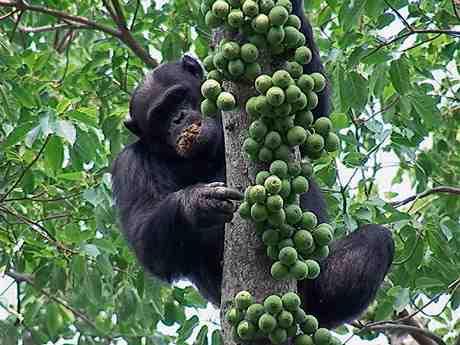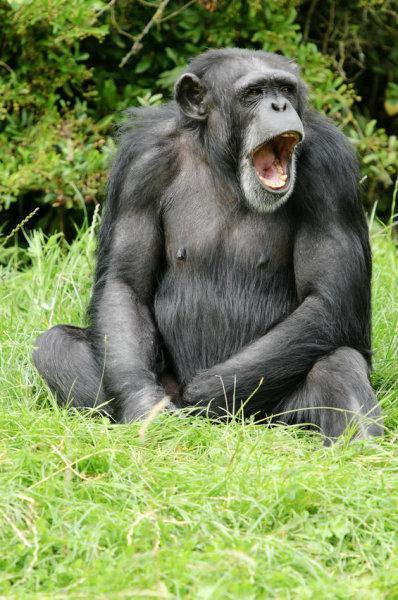The first image is the image on the left, the second image is the image on the right. Evaluate the accuracy of this statement regarding the images: "At least one chimp is squatting on a somewhat horizontal branch, surrounded by foliage.". Is it true? Answer yes or no. No. The first image is the image on the left, the second image is the image on the right. Analyze the images presented: Is the assertion "There are chimpanzees sitting on a suspended tree branch." valid? Answer yes or no. No. 